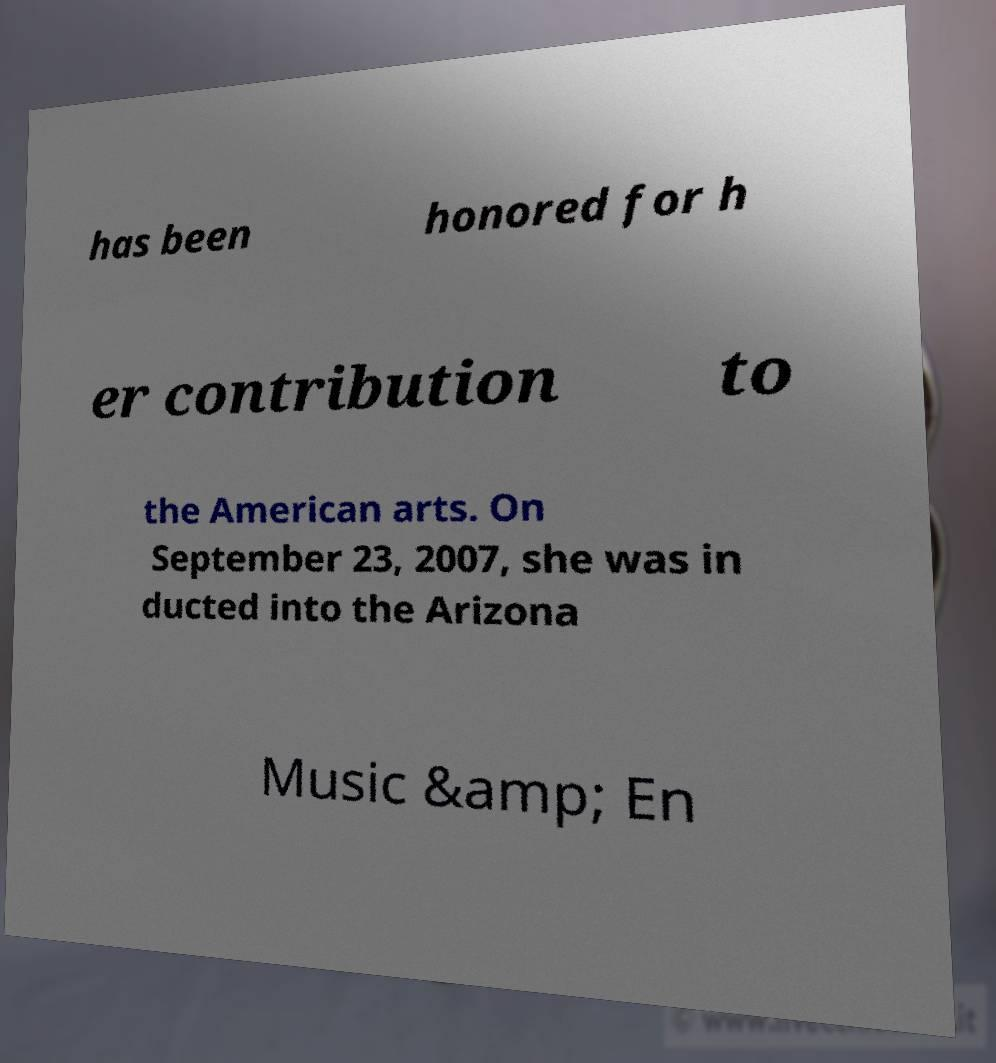Can you read and provide the text displayed in the image?This photo seems to have some interesting text. Can you extract and type it out for me? has been honored for h er contribution to the American arts. On September 23, 2007, she was in ducted into the Arizona Music &amp; En 